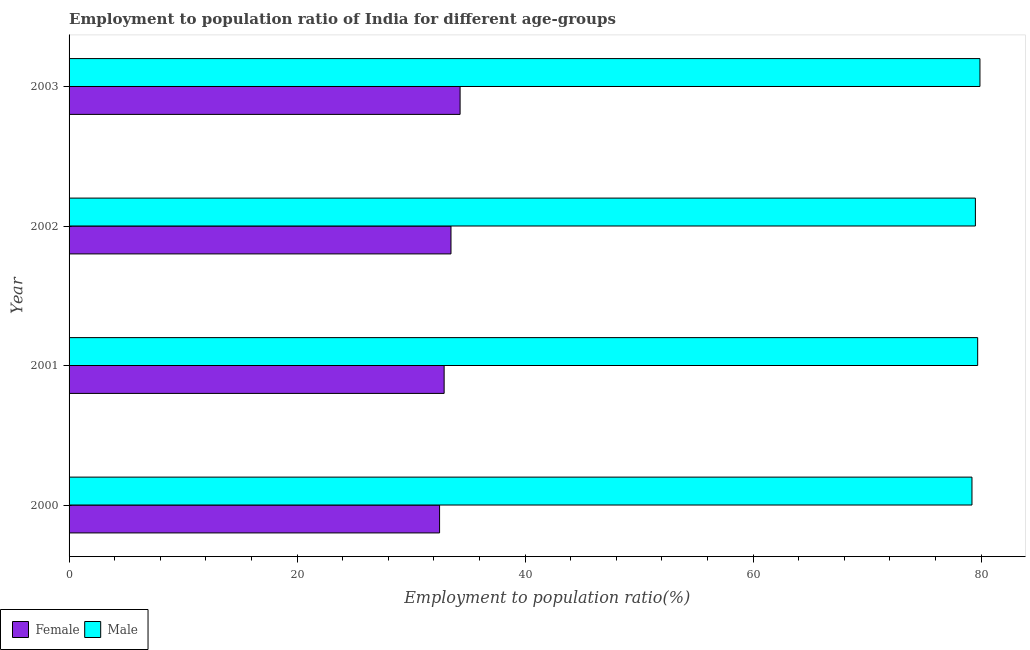Are the number of bars per tick equal to the number of legend labels?
Make the answer very short. Yes. How many bars are there on the 3rd tick from the bottom?
Ensure brevity in your answer.  2. What is the label of the 1st group of bars from the top?
Provide a succinct answer. 2003. In how many cases, is the number of bars for a given year not equal to the number of legend labels?
Provide a short and direct response. 0. What is the employment to population ratio(female) in 2002?
Keep it short and to the point. 33.5. Across all years, what is the maximum employment to population ratio(male)?
Give a very brief answer. 79.9. Across all years, what is the minimum employment to population ratio(male)?
Offer a terse response. 79.2. In which year was the employment to population ratio(male) minimum?
Provide a short and direct response. 2000. What is the total employment to population ratio(male) in the graph?
Give a very brief answer. 318.3. What is the difference between the employment to population ratio(male) in 2001 and that in 2003?
Your answer should be compact. -0.2. What is the difference between the employment to population ratio(female) in 2002 and the employment to population ratio(male) in 2001?
Offer a terse response. -46.2. What is the average employment to population ratio(male) per year?
Give a very brief answer. 79.58. In the year 2001, what is the difference between the employment to population ratio(male) and employment to population ratio(female)?
Provide a succinct answer. 46.8. What is the ratio of the employment to population ratio(male) in 2000 to that in 2001?
Provide a short and direct response. 0.99. Is the difference between the employment to population ratio(female) in 2001 and 2002 greater than the difference between the employment to population ratio(male) in 2001 and 2002?
Your answer should be very brief. No. What is the difference between the highest and the second highest employment to population ratio(male)?
Your answer should be compact. 0.2. In how many years, is the employment to population ratio(male) greater than the average employment to population ratio(male) taken over all years?
Provide a short and direct response. 2. What does the 2nd bar from the top in 2001 represents?
Give a very brief answer. Female. What does the 1st bar from the bottom in 2000 represents?
Offer a very short reply. Female. Are all the bars in the graph horizontal?
Provide a succinct answer. Yes. Does the graph contain any zero values?
Offer a very short reply. No. Where does the legend appear in the graph?
Make the answer very short. Bottom left. How many legend labels are there?
Provide a succinct answer. 2. What is the title of the graph?
Your answer should be very brief. Employment to population ratio of India for different age-groups. Does "Automatic Teller Machines" appear as one of the legend labels in the graph?
Provide a short and direct response. No. What is the label or title of the X-axis?
Provide a short and direct response. Employment to population ratio(%). What is the label or title of the Y-axis?
Offer a very short reply. Year. What is the Employment to population ratio(%) in Female in 2000?
Ensure brevity in your answer.  32.5. What is the Employment to population ratio(%) in Male in 2000?
Offer a very short reply. 79.2. What is the Employment to population ratio(%) in Female in 2001?
Ensure brevity in your answer.  32.9. What is the Employment to population ratio(%) in Male in 2001?
Your answer should be compact. 79.7. What is the Employment to population ratio(%) in Female in 2002?
Make the answer very short. 33.5. What is the Employment to population ratio(%) in Male in 2002?
Keep it short and to the point. 79.5. What is the Employment to population ratio(%) of Female in 2003?
Keep it short and to the point. 34.3. What is the Employment to population ratio(%) in Male in 2003?
Your answer should be very brief. 79.9. Across all years, what is the maximum Employment to population ratio(%) in Female?
Ensure brevity in your answer.  34.3. Across all years, what is the maximum Employment to population ratio(%) of Male?
Give a very brief answer. 79.9. Across all years, what is the minimum Employment to population ratio(%) in Female?
Ensure brevity in your answer.  32.5. Across all years, what is the minimum Employment to population ratio(%) of Male?
Give a very brief answer. 79.2. What is the total Employment to population ratio(%) of Female in the graph?
Provide a short and direct response. 133.2. What is the total Employment to population ratio(%) of Male in the graph?
Your response must be concise. 318.3. What is the difference between the Employment to population ratio(%) in Female in 2000 and that in 2001?
Provide a succinct answer. -0.4. What is the difference between the Employment to population ratio(%) in Female in 2000 and that in 2002?
Offer a very short reply. -1. What is the difference between the Employment to population ratio(%) in Male in 2000 and that in 2002?
Ensure brevity in your answer.  -0.3. What is the difference between the Employment to population ratio(%) in Female in 2000 and that in 2003?
Your response must be concise. -1.8. What is the difference between the Employment to population ratio(%) of Male in 2000 and that in 2003?
Provide a short and direct response. -0.7. What is the difference between the Employment to population ratio(%) of Female in 2001 and that in 2002?
Provide a succinct answer. -0.6. What is the difference between the Employment to population ratio(%) in Male in 2001 and that in 2003?
Offer a very short reply. -0.2. What is the difference between the Employment to population ratio(%) of Female in 2002 and that in 2003?
Make the answer very short. -0.8. What is the difference between the Employment to population ratio(%) in Male in 2002 and that in 2003?
Keep it short and to the point. -0.4. What is the difference between the Employment to population ratio(%) of Female in 2000 and the Employment to population ratio(%) of Male in 2001?
Provide a short and direct response. -47.2. What is the difference between the Employment to population ratio(%) in Female in 2000 and the Employment to population ratio(%) in Male in 2002?
Your response must be concise. -47. What is the difference between the Employment to population ratio(%) in Female in 2000 and the Employment to population ratio(%) in Male in 2003?
Make the answer very short. -47.4. What is the difference between the Employment to population ratio(%) of Female in 2001 and the Employment to population ratio(%) of Male in 2002?
Give a very brief answer. -46.6. What is the difference between the Employment to population ratio(%) in Female in 2001 and the Employment to population ratio(%) in Male in 2003?
Your answer should be very brief. -47. What is the difference between the Employment to population ratio(%) of Female in 2002 and the Employment to population ratio(%) of Male in 2003?
Your answer should be very brief. -46.4. What is the average Employment to population ratio(%) in Female per year?
Your answer should be compact. 33.3. What is the average Employment to population ratio(%) of Male per year?
Provide a short and direct response. 79.58. In the year 2000, what is the difference between the Employment to population ratio(%) in Female and Employment to population ratio(%) in Male?
Provide a succinct answer. -46.7. In the year 2001, what is the difference between the Employment to population ratio(%) in Female and Employment to population ratio(%) in Male?
Your response must be concise. -46.8. In the year 2002, what is the difference between the Employment to population ratio(%) of Female and Employment to population ratio(%) of Male?
Your response must be concise. -46. In the year 2003, what is the difference between the Employment to population ratio(%) in Female and Employment to population ratio(%) in Male?
Provide a short and direct response. -45.6. What is the ratio of the Employment to population ratio(%) in Female in 2000 to that in 2001?
Keep it short and to the point. 0.99. What is the ratio of the Employment to population ratio(%) in Female in 2000 to that in 2002?
Your response must be concise. 0.97. What is the ratio of the Employment to population ratio(%) in Male in 2000 to that in 2002?
Your response must be concise. 1. What is the ratio of the Employment to population ratio(%) in Female in 2000 to that in 2003?
Offer a very short reply. 0.95. What is the ratio of the Employment to population ratio(%) of Male in 2000 to that in 2003?
Make the answer very short. 0.99. What is the ratio of the Employment to population ratio(%) in Female in 2001 to that in 2002?
Provide a succinct answer. 0.98. What is the ratio of the Employment to population ratio(%) in Female in 2001 to that in 2003?
Give a very brief answer. 0.96. What is the ratio of the Employment to population ratio(%) of Female in 2002 to that in 2003?
Your answer should be compact. 0.98. What is the difference between the highest and the second highest Employment to population ratio(%) in Male?
Give a very brief answer. 0.2. 